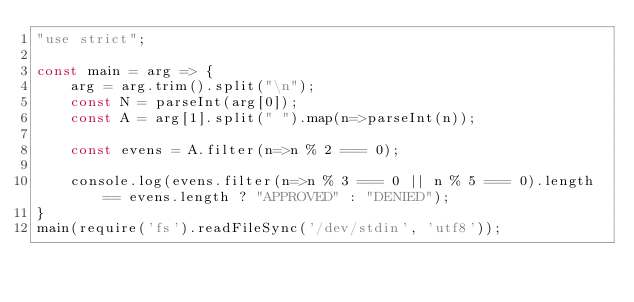Convert code to text. <code><loc_0><loc_0><loc_500><loc_500><_JavaScript_>"use strict";
    
const main = arg => {
    arg = arg.trim().split("\n");
    const N = parseInt(arg[0]);
    const A = arg[1].split(" ").map(n=>parseInt(n));
    
    const evens = A.filter(n=>n % 2 === 0);
    
    console.log(evens.filter(n=>n % 3 === 0 || n % 5 === 0).length == evens.length ? "APPROVED" : "DENIED");
}
main(require('fs').readFileSync('/dev/stdin', 'utf8'));</code> 